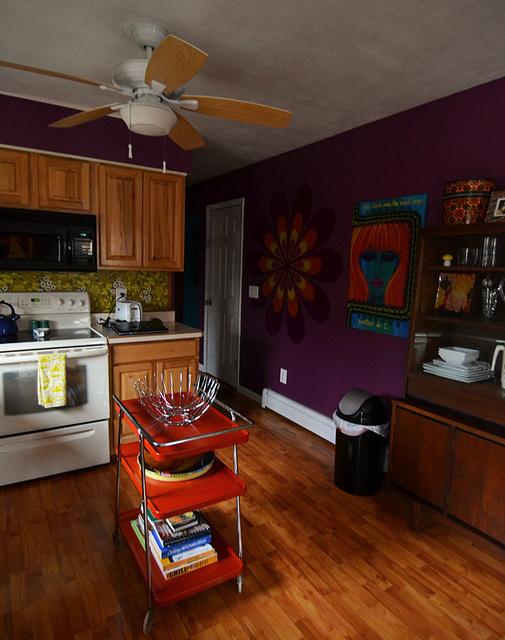What color is the waste bin?
Write a very short answer. Black. What color is the kitchen cart?
Quick response, please. Red. Is the decor modern?
Answer briefly. Yes. 